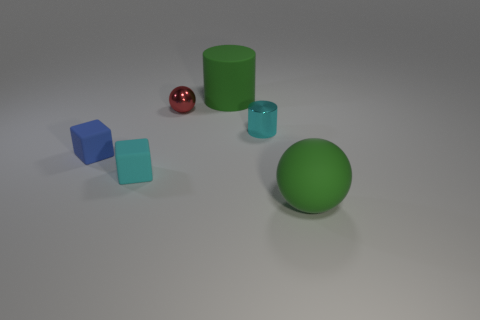Add 1 green cylinders. How many objects exist? 7 Subtract all spheres. How many objects are left? 4 Subtract all red balls. How many balls are left? 1 Subtract 1 cubes. How many cubes are left? 1 Subtract all purple matte cylinders. Subtract all small matte things. How many objects are left? 4 Add 1 tiny blocks. How many tiny blocks are left? 3 Add 1 red spheres. How many red spheres exist? 2 Subtract 0 purple cylinders. How many objects are left? 6 Subtract all cyan cubes. Subtract all blue cylinders. How many cubes are left? 1 Subtract all blue balls. How many blue blocks are left? 1 